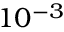Convert formula to latex. <formula><loc_0><loc_0><loc_500><loc_500>1 0 ^ { - 3 }</formula> 